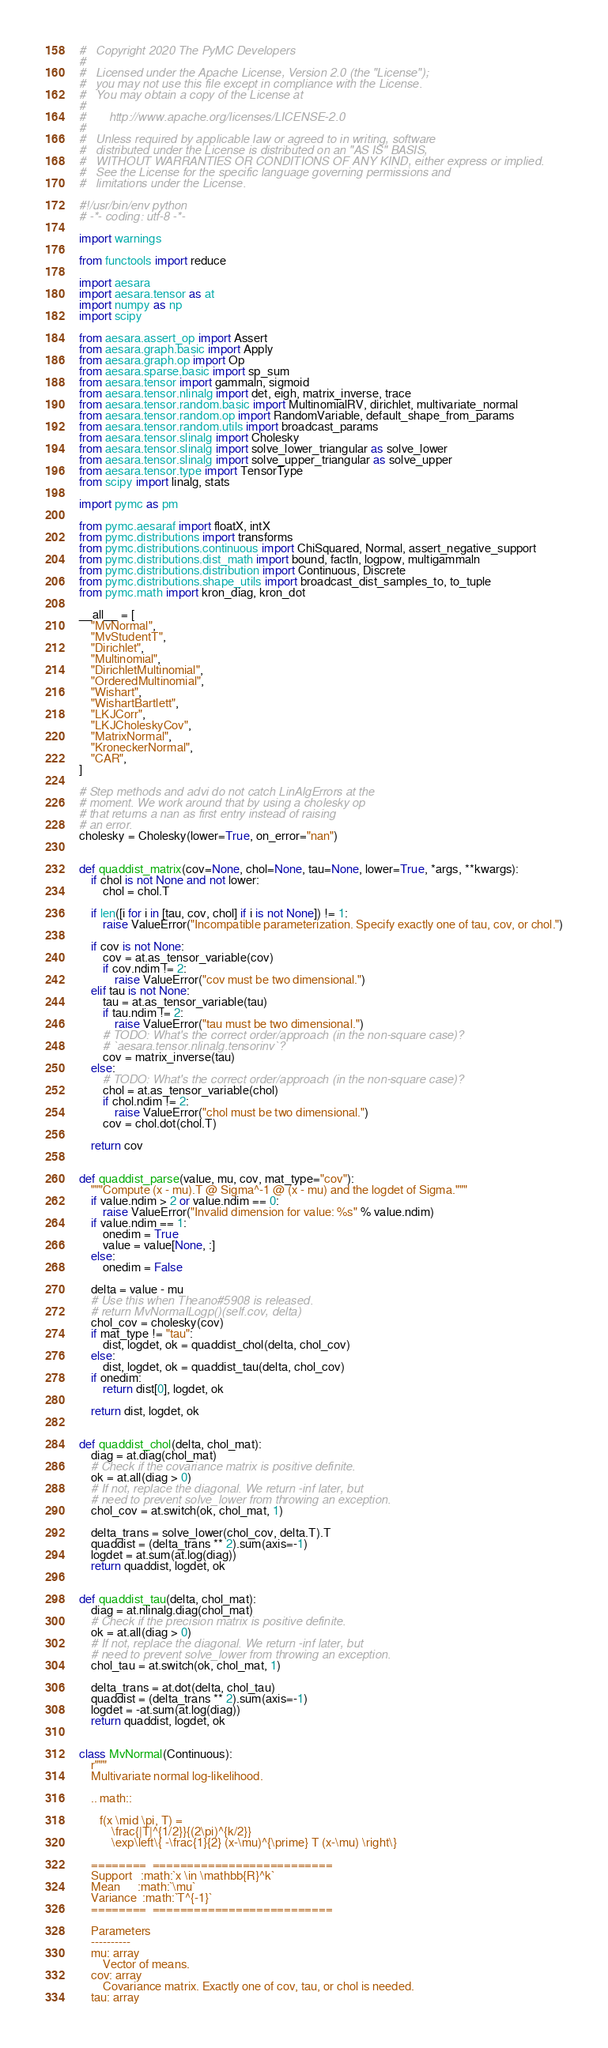Convert code to text. <code><loc_0><loc_0><loc_500><loc_500><_Python_>#   Copyright 2020 The PyMC Developers
#
#   Licensed under the Apache License, Version 2.0 (the "License");
#   you may not use this file except in compliance with the License.
#   You may obtain a copy of the License at
#
#       http://www.apache.org/licenses/LICENSE-2.0
#
#   Unless required by applicable law or agreed to in writing, software
#   distributed under the License is distributed on an "AS IS" BASIS,
#   WITHOUT WARRANTIES OR CONDITIONS OF ANY KIND, either express or implied.
#   See the License for the specific language governing permissions and
#   limitations under the License.

#!/usr/bin/env python
# -*- coding: utf-8 -*-

import warnings

from functools import reduce

import aesara
import aesara.tensor as at
import numpy as np
import scipy

from aesara.assert_op import Assert
from aesara.graph.basic import Apply
from aesara.graph.op import Op
from aesara.sparse.basic import sp_sum
from aesara.tensor import gammaln, sigmoid
from aesara.tensor.nlinalg import det, eigh, matrix_inverse, trace
from aesara.tensor.random.basic import MultinomialRV, dirichlet, multivariate_normal
from aesara.tensor.random.op import RandomVariable, default_shape_from_params
from aesara.tensor.random.utils import broadcast_params
from aesara.tensor.slinalg import Cholesky
from aesara.tensor.slinalg import solve_lower_triangular as solve_lower
from aesara.tensor.slinalg import solve_upper_triangular as solve_upper
from aesara.tensor.type import TensorType
from scipy import linalg, stats

import pymc as pm

from pymc.aesaraf import floatX, intX
from pymc.distributions import transforms
from pymc.distributions.continuous import ChiSquared, Normal, assert_negative_support
from pymc.distributions.dist_math import bound, factln, logpow, multigammaln
from pymc.distributions.distribution import Continuous, Discrete
from pymc.distributions.shape_utils import broadcast_dist_samples_to, to_tuple
from pymc.math import kron_diag, kron_dot

__all__ = [
    "MvNormal",
    "MvStudentT",
    "Dirichlet",
    "Multinomial",
    "DirichletMultinomial",
    "OrderedMultinomial",
    "Wishart",
    "WishartBartlett",
    "LKJCorr",
    "LKJCholeskyCov",
    "MatrixNormal",
    "KroneckerNormal",
    "CAR",
]

# Step methods and advi do not catch LinAlgErrors at the
# moment. We work around that by using a cholesky op
# that returns a nan as first entry instead of raising
# an error.
cholesky = Cholesky(lower=True, on_error="nan")


def quaddist_matrix(cov=None, chol=None, tau=None, lower=True, *args, **kwargs):
    if chol is not None and not lower:
        chol = chol.T

    if len([i for i in [tau, cov, chol] if i is not None]) != 1:
        raise ValueError("Incompatible parameterization. Specify exactly one of tau, cov, or chol.")

    if cov is not None:
        cov = at.as_tensor_variable(cov)
        if cov.ndim != 2:
            raise ValueError("cov must be two dimensional.")
    elif tau is not None:
        tau = at.as_tensor_variable(tau)
        if tau.ndim != 2:
            raise ValueError("tau must be two dimensional.")
        # TODO: What's the correct order/approach (in the non-square case)?
        # `aesara.tensor.nlinalg.tensorinv`?
        cov = matrix_inverse(tau)
    else:
        # TODO: What's the correct order/approach (in the non-square case)?
        chol = at.as_tensor_variable(chol)
        if chol.ndim != 2:
            raise ValueError("chol must be two dimensional.")
        cov = chol.dot(chol.T)

    return cov


def quaddist_parse(value, mu, cov, mat_type="cov"):
    """Compute (x - mu).T @ Sigma^-1 @ (x - mu) and the logdet of Sigma."""
    if value.ndim > 2 or value.ndim == 0:
        raise ValueError("Invalid dimension for value: %s" % value.ndim)
    if value.ndim == 1:
        onedim = True
        value = value[None, :]
    else:
        onedim = False

    delta = value - mu
    # Use this when Theano#5908 is released.
    # return MvNormalLogp()(self.cov, delta)
    chol_cov = cholesky(cov)
    if mat_type != "tau":
        dist, logdet, ok = quaddist_chol(delta, chol_cov)
    else:
        dist, logdet, ok = quaddist_tau(delta, chol_cov)
    if onedim:
        return dist[0], logdet, ok

    return dist, logdet, ok


def quaddist_chol(delta, chol_mat):
    diag = at.diag(chol_mat)
    # Check if the covariance matrix is positive definite.
    ok = at.all(diag > 0)
    # If not, replace the diagonal. We return -inf later, but
    # need to prevent solve_lower from throwing an exception.
    chol_cov = at.switch(ok, chol_mat, 1)

    delta_trans = solve_lower(chol_cov, delta.T).T
    quaddist = (delta_trans ** 2).sum(axis=-1)
    logdet = at.sum(at.log(diag))
    return quaddist, logdet, ok


def quaddist_tau(delta, chol_mat):
    diag = at.nlinalg.diag(chol_mat)
    # Check if the precision matrix is positive definite.
    ok = at.all(diag > 0)
    # If not, replace the diagonal. We return -inf later, but
    # need to prevent solve_lower from throwing an exception.
    chol_tau = at.switch(ok, chol_mat, 1)

    delta_trans = at.dot(delta, chol_tau)
    quaddist = (delta_trans ** 2).sum(axis=-1)
    logdet = -at.sum(at.log(diag))
    return quaddist, logdet, ok


class MvNormal(Continuous):
    r"""
    Multivariate normal log-likelihood.

    .. math::

       f(x \mid \pi, T) =
           \frac{|T|^{1/2}}{(2\pi)^{k/2}}
           \exp\left\{ -\frac{1}{2} (x-\mu)^{\prime} T (x-\mu) \right\}

    ========  ==========================
    Support   :math:`x \in \mathbb{R}^k`
    Mean      :math:`\mu`
    Variance  :math:`T^{-1}`
    ========  ==========================

    Parameters
    ----------
    mu: array
        Vector of means.
    cov: array
        Covariance matrix. Exactly one of cov, tau, or chol is needed.
    tau: array</code> 